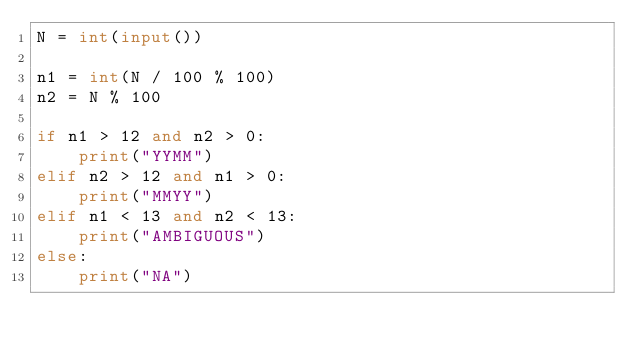Convert code to text. <code><loc_0><loc_0><loc_500><loc_500><_Python_>N = int(input())

n1 = int(N / 100 % 100)
n2 = N % 100

if n1 > 12 and n2 > 0:
    print("YYMM")
elif n2 > 12 and n1 > 0:
    print("MMYY")
elif n1 < 13 and n2 < 13:
    print("AMBIGUOUS")
else:
    print("NA")
</code> 